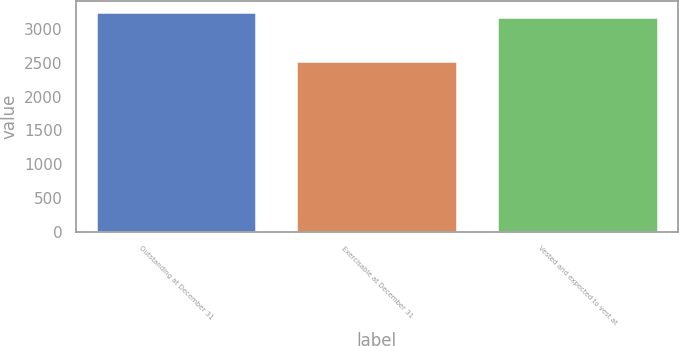Convert chart to OTSL. <chart><loc_0><loc_0><loc_500><loc_500><bar_chart><fcel>Outstanding at December 31<fcel>Exercisable at December 31<fcel>Vested and expected to vest at<nl><fcel>3246.5<fcel>2527<fcel>3178<nl></chart> 